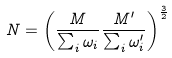<formula> <loc_0><loc_0><loc_500><loc_500>N = \left ( \frac { M } { \sum _ { i } { \omega _ { i } } } \frac { M ^ { \prime } } { \sum _ { i } { \omega ^ { \prime } _ { i } } } \right ) ^ { \frac { 3 } { 2 } }</formula> 